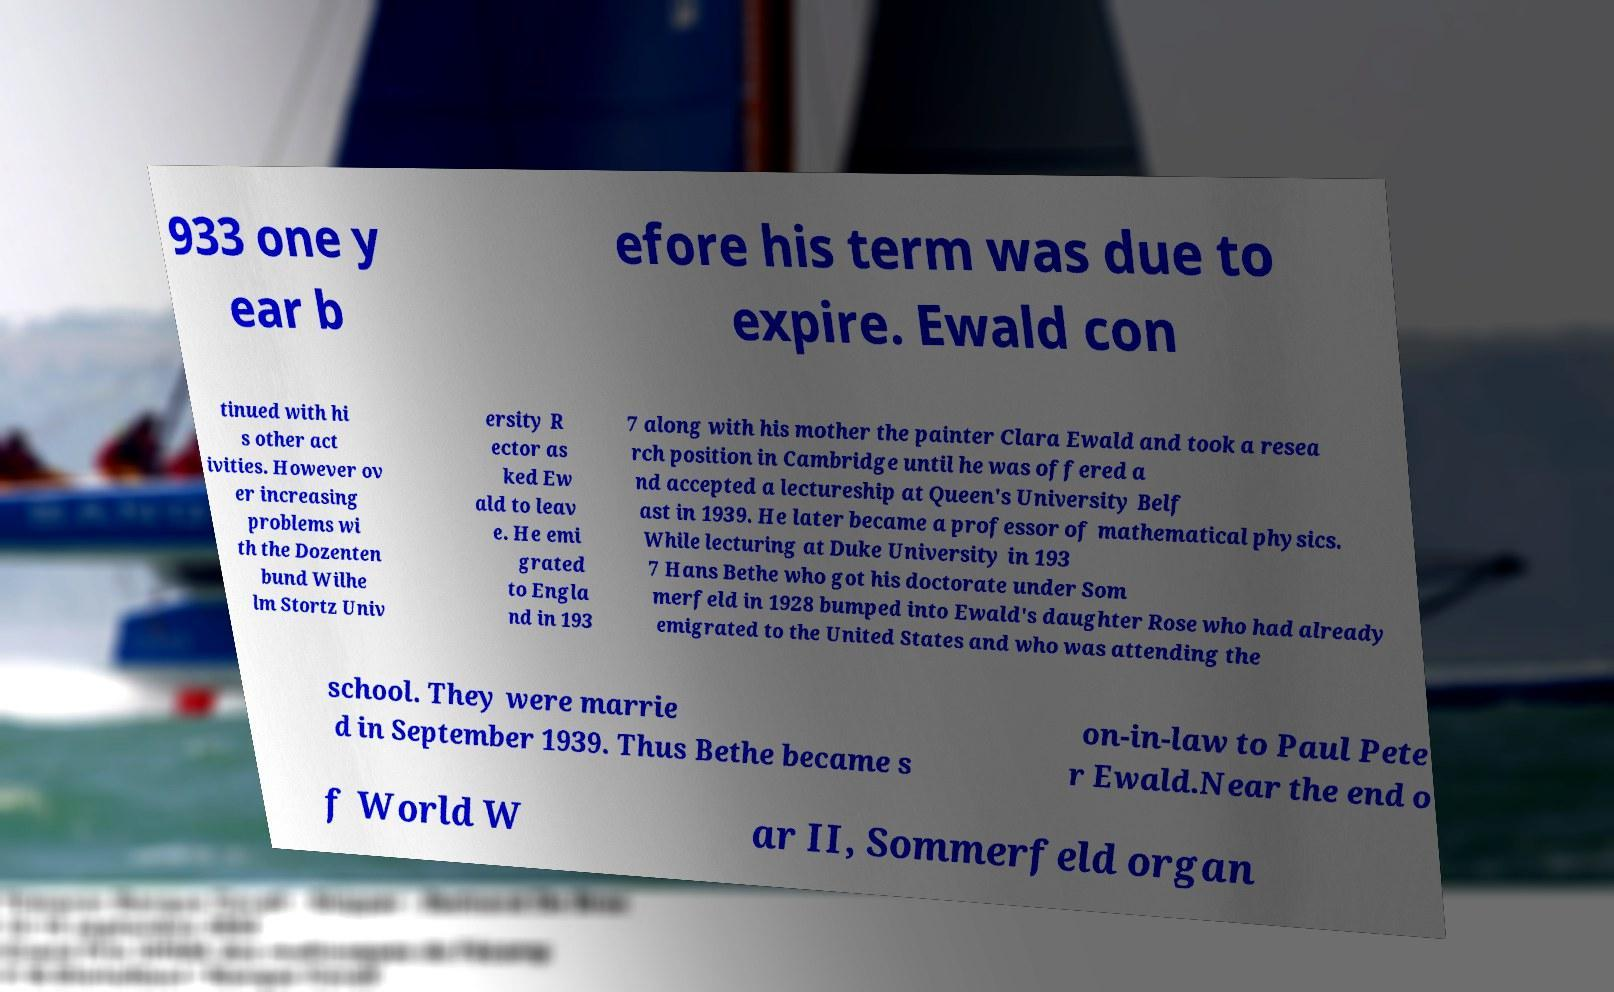Could you extract and type out the text from this image? 933 one y ear b efore his term was due to expire. Ewald con tinued with hi s other act ivities. However ov er increasing problems wi th the Dozenten bund Wilhe lm Stortz Univ ersity R ector as ked Ew ald to leav e. He emi grated to Engla nd in 193 7 along with his mother the painter Clara Ewald and took a resea rch position in Cambridge until he was offered a nd accepted a lectureship at Queen's University Belf ast in 1939. He later became a professor of mathematical physics. While lecturing at Duke University in 193 7 Hans Bethe who got his doctorate under Som merfeld in 1928 bumped into Ewald's daughter Rose who had already emigrated to the United States and who was attending the school. They were marrie d in September 1939. Thus Bethe became s on-in-law to Paul Pete r Ewald.Near the end o f World W ar II, Sommerfeld organ 